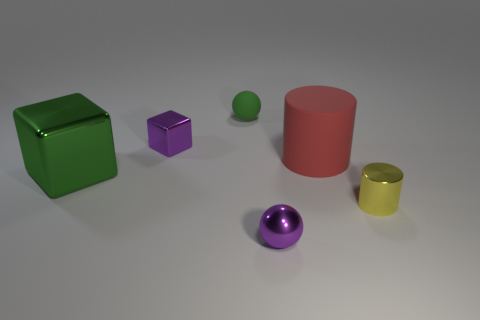Is the small sphere that is behind the large metallic cube made of the same material as the tiny yellow cylinder?
Give a very brief answer. No. The ball that is the same material as the red object is what color?
Offer a very short reply. Green. Is the number of green things to the right of the large green thing less than the number of large red matte cylinders that are left of the big rubber object?
Provide a succinct answer. No. There is a block that is in front of the big red cylinder; does it have the same color as the rubber object that is in front of the small purple metallic block?
Offer a very short reply. No. Are there any purple objects that have the same material as the green ball?
Your response must be concise. No. There is a metallic thing that is on the left side of the purple object behind the big green shiny object; how big is it?
Ensure brevity in your answer.  Large. Is the number of small purple objects greater than the number of small purple metal cubes?
Your response must be concise. Yes. Does the purple metal thing to the right of the green ball have the same size as the red matte thing?
Your response must be concise. No. How many small balls have the same color as the big metallic cube?
Ensure brevity in your answer.  1. Do the red rubber thing and the tiny yellow metallic thing have the same shape?
Provide a succinct answer. Yes. 